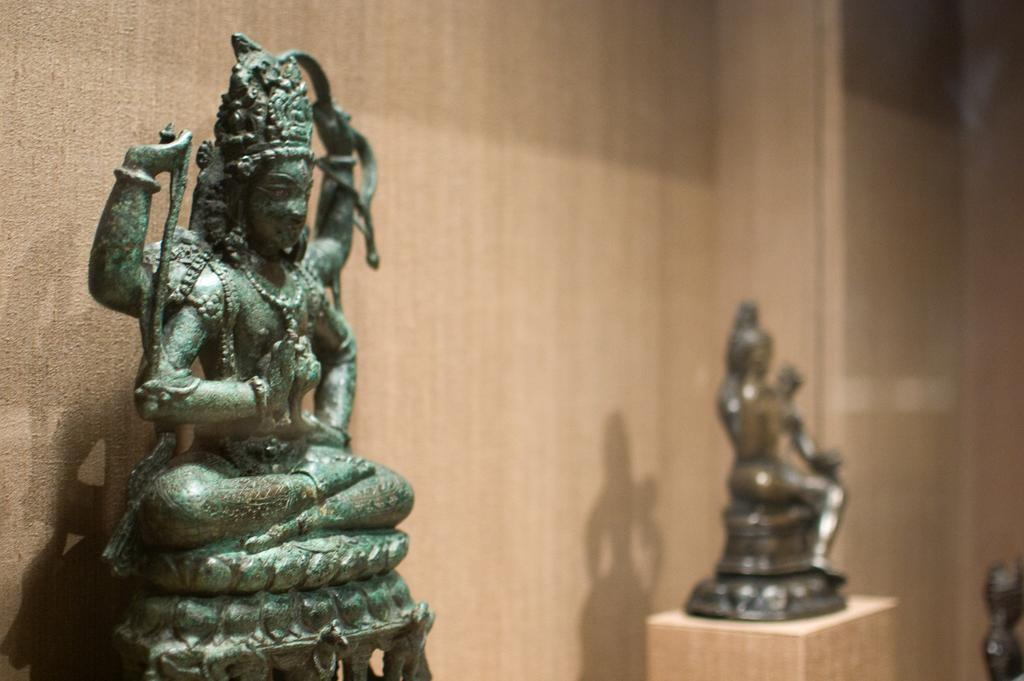What can be seen on the pillars in the image? There are idols on pillars in the image. What is visible in the background of the image? There is a wall in the background of the image. What type of cannon is present in the image? There is no cannon present in the image. How much rice is visible in the image? There is no rice present in the image. 